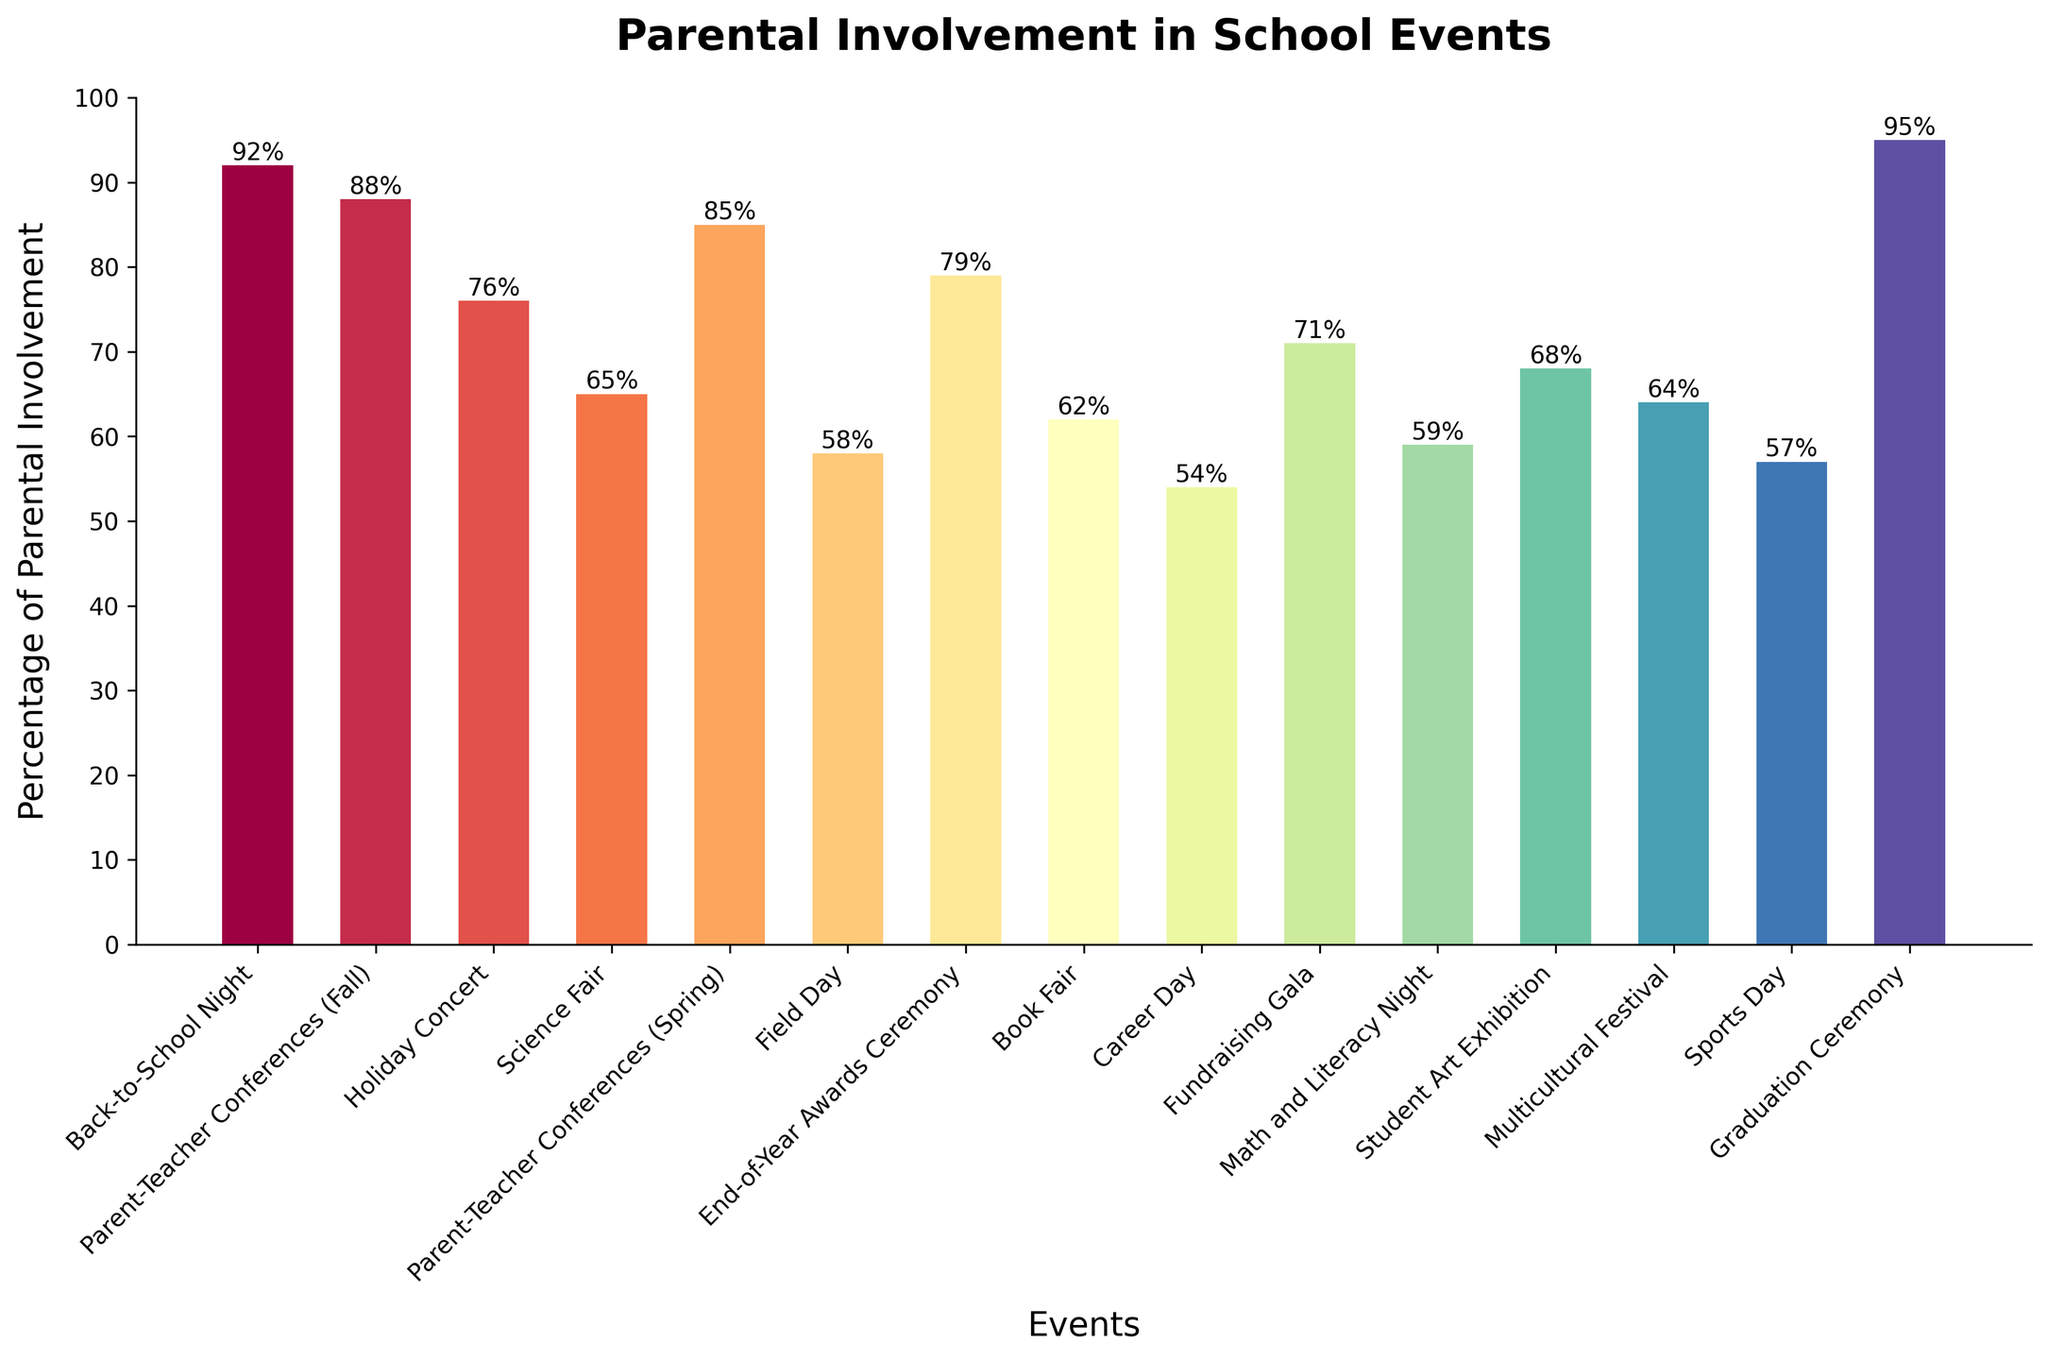Which event has the highest percentage of parental involvement? The highest bar on the figure represents the Graduation Ceremony. The height of this bar is marked at 95%.
Answer: Graduation Ceremony What is the percentage difference in parental involvement between the Book Fair and the Fundraising Gala? The bar for the Book Fair shows a percentage of 62%, and the bar for the Fundraising Gala shows 71%. The difference is calculated as 71% - 62% = 9%.
Answer: 9% Which event has the lowest parental involvement, and what is the percentage? The Career Day bar is the shortest on the figure, indicating the lowest parental involvement at 54%.
Answer: Career Day, 54% What is the average parental involvement percentage for Parent-Teacher Conferences in Fall and Spring? The Parent-Teacher Conferences (Fall) has a percentage of 88%, and Spring has 85%. The average is calculated as (88% + 85%) / 2 = 86.5%.
Answer: 86.5% How does the parental involvement in the Holiday Concert compare to the Science Fair? The bar for the Holiday Concert is at 76%, and the bar for the Science Fair is at 65%. The Holiday Concert has a higher parental involvement by 11%.
Answer: Holiday Concert is 11% higher Which event has a slightly higher parental involvement: Math and Literacy Night or Student Art Exhibition? The bar for Math and Literacy Night is at 59%, while the bar for Student Art Exhibition is at 68%. The Student Art Exhibition has a higher involvement by 9%.
Answer: Student Art Exhibition What is the sum of parental involvement percentages for Field Day, Sports Day, and Career Day? The percentages are Field Day (58%), Sports Day (57%), and Career Day (54%). The sum is 58% + 57% + 54% = 169%.
Answer: 169% Are there more events with a parental involvement percentage above or below 60%? Count the bars above 60% and those below 60%. Above 60%: 11 events, Below 60%: 4 events. The number above 60% is larger.
Answer: Above 60% What is the median percentage of parental involvement for all events? List the percentages in ascending order: 54, 57, 58, 59, 62, 64, 65, 68, 71, 76, 79, 85, 88, 92, 95. The median is the 8th value: 68%.
Answer: 68% Which color represents the Back-to-School Night event, and what is its percentage of parental involvement? The Back-to-School Night bar is towards the left of the figure, representing a percentage of 92%. The colors are in a spectrum but generally, it's among the initial colors in the color gradient used.
Answer: 92% 